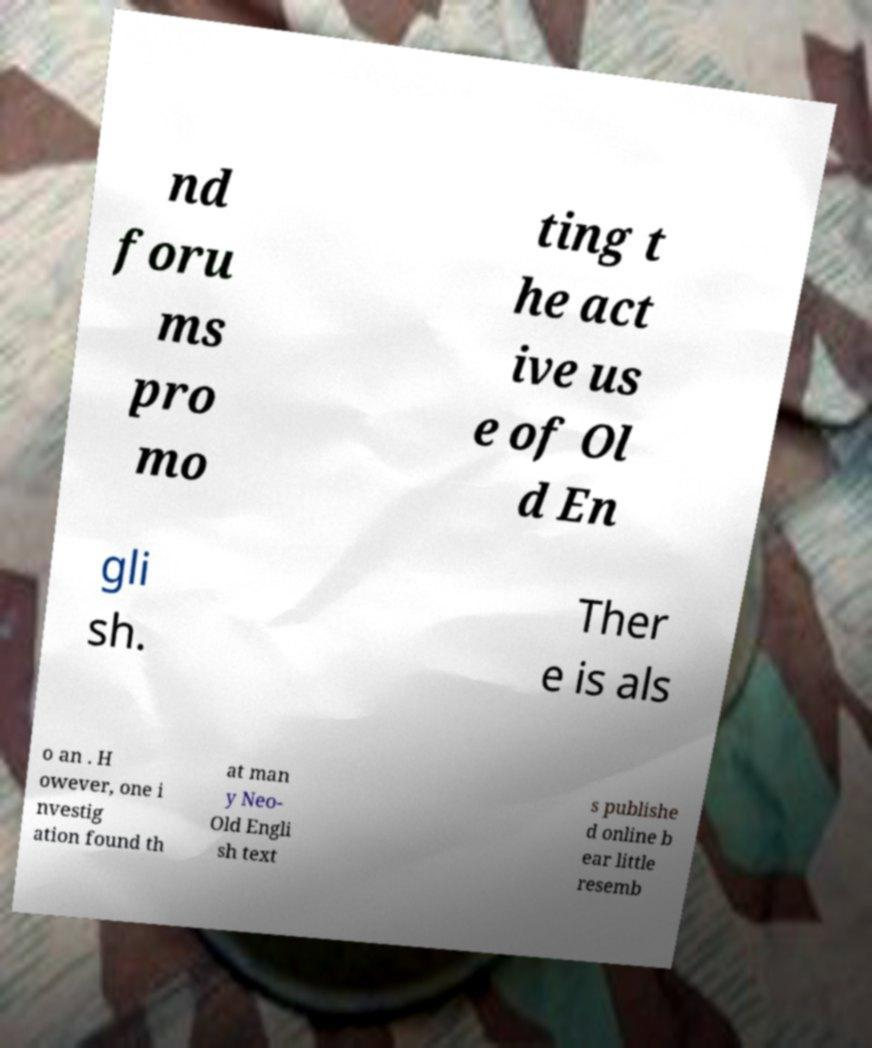Please read and relay the text visible in this image. What does it say? nd foru ms pro mo ting t he act ive us e of Ol d En gli sh. Ther e is als o an . H owever, one i nvestig ation found th at man y Neo- Old Engli sh text s publishe d online b ear little resemb 